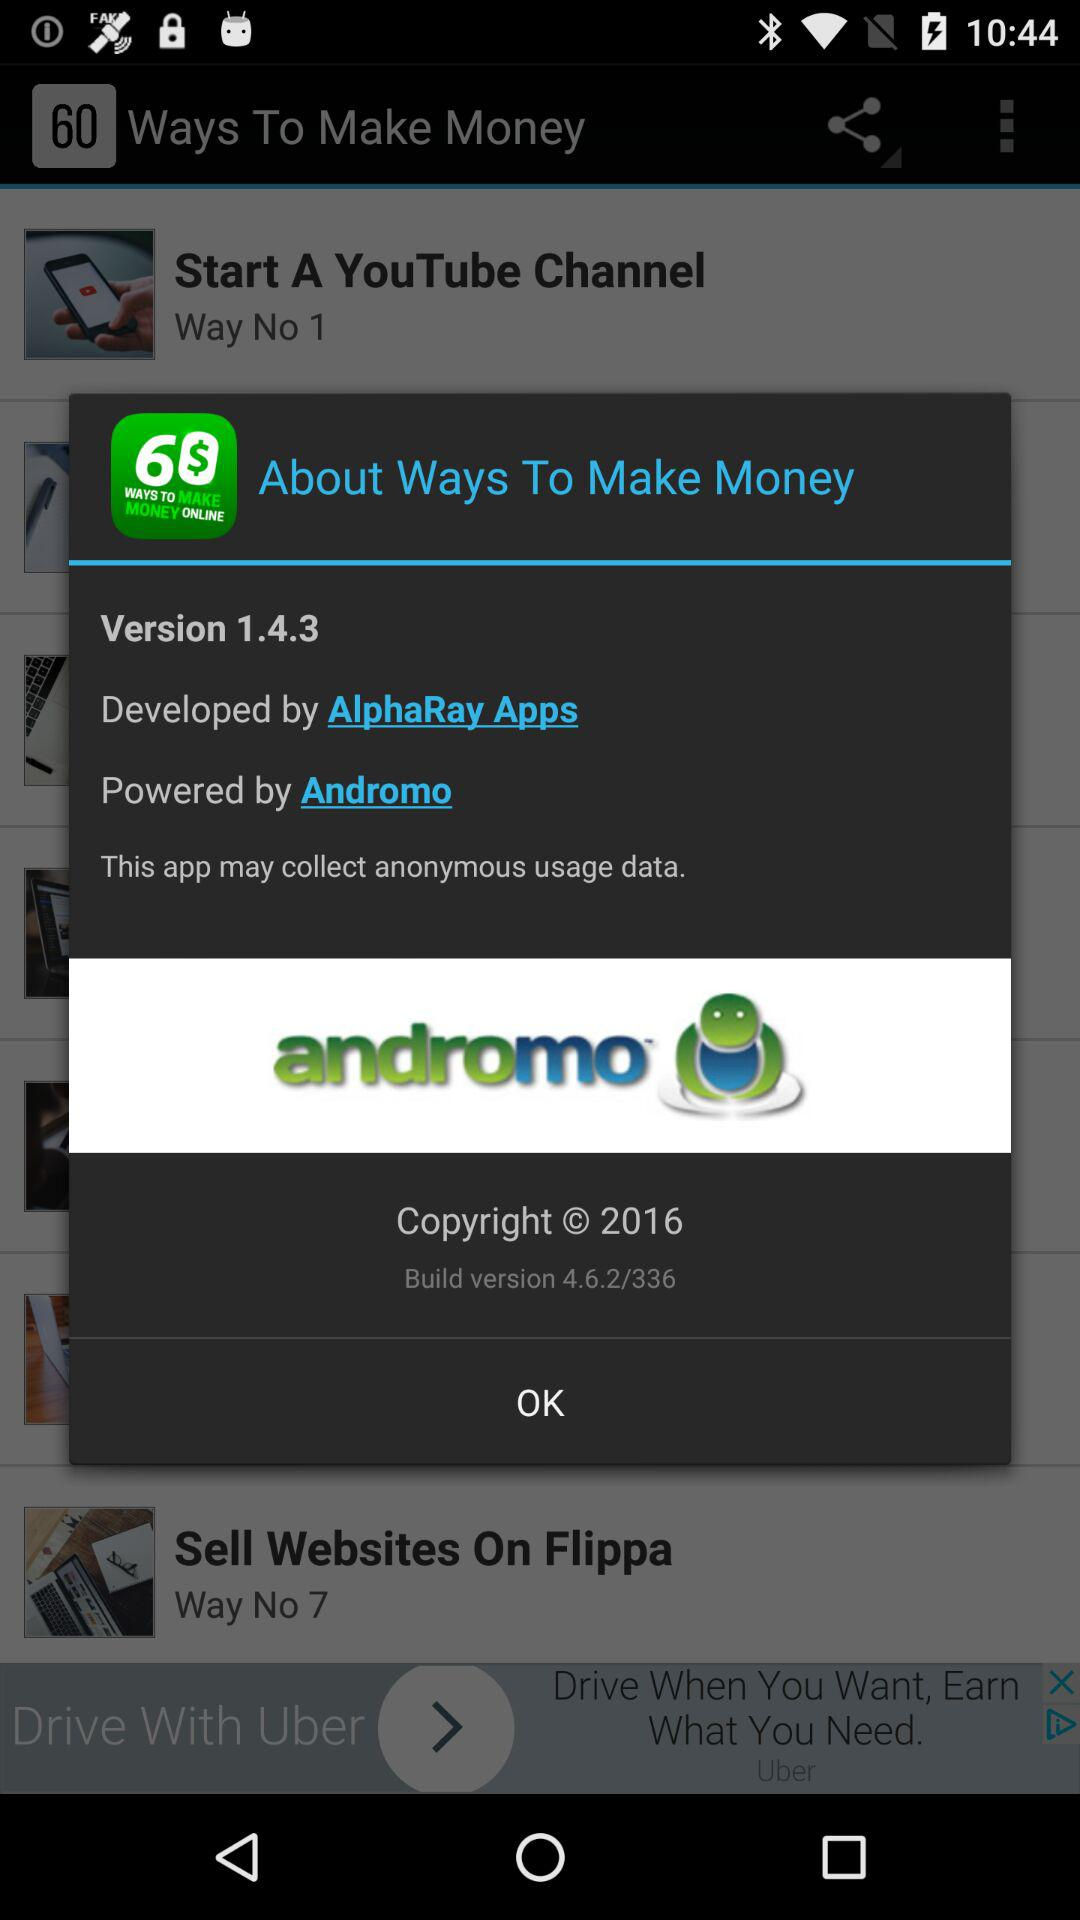Which is the build version? The build version is 4.6.2/336. 